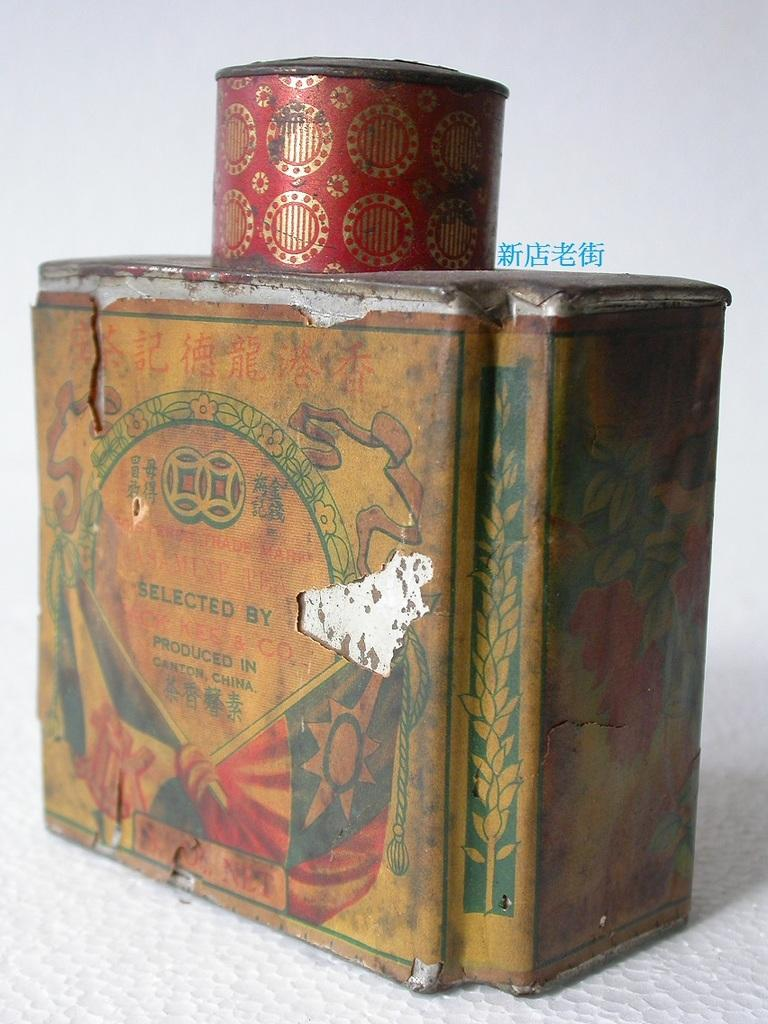What can be seen in the image? There is an object in the image. What is the color of the surface the object is placed on? The object is on a white surface. Is there any text or information on the object? Yes, there is a label on the object. What type of bell can be heard ringing in the image? There is no bell present in the image, and therefore no sound can be heard. 